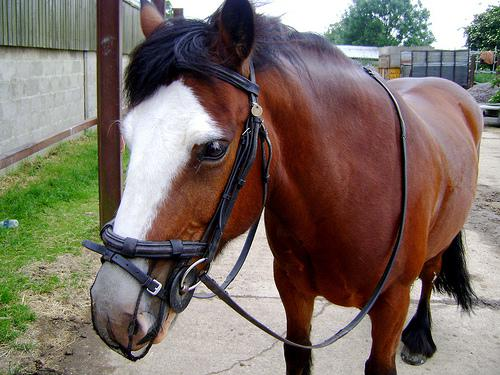Question: what is the horse doing?
Choices:
A. Standing.
B. Walking.
C. Galloping.
D. Eating.
Answer with the letter. Answer: A Question: who is the horse looking at?
Choices:
A. The children.
B. The cameraman.
C. The men.
D. The females.
Answer with the letter. Answer: B Question: how is the horse being held?
Choices:
A. With a bridle.
B. With a harness.
C. With a rope.
D. With a strap.
Answer with the letter. Answer: B Question: when is this picture taken?
Choices:
A. During the night.
B. During the afternoon.
C. In the morning.
D. During the day.
Answer with the letter. Answer: D 